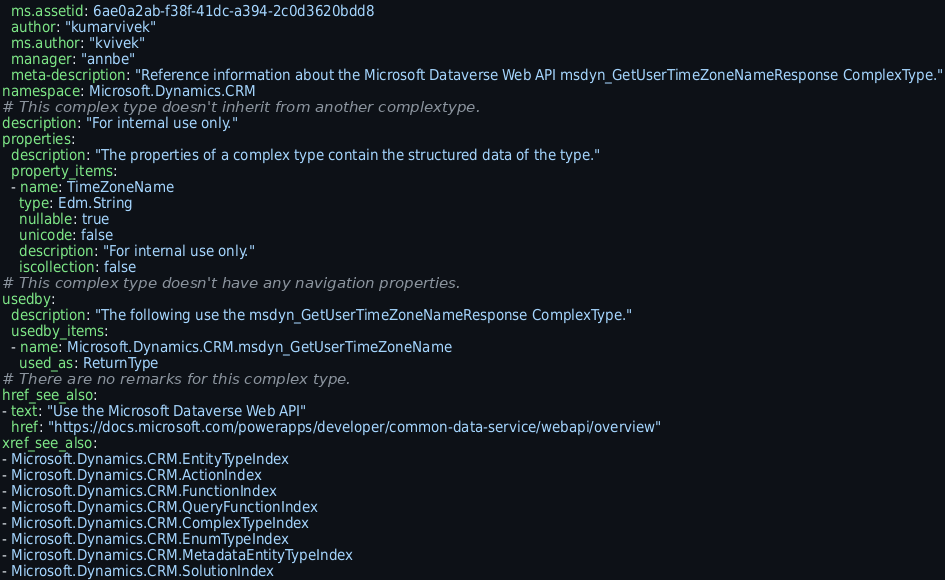<code> <loc_0><loc_0><loc_500><loc_500><_YAML_>  ms.assetid: 6ae0a2ab-f38f-41dc-a394-2c0d3620bdd8
  author: "kumarvivek"
  ms.author: "kvivek"
  manager: "annbe"
  meta-description: "Reference information about the Microsoft Dataverse Web API msdyn_GetUserTimeZoneNameResponse ComplexType."
namespace: Microsoft.Dynamics.CRM
# This complex type doesn't inherit from another complextype.
description: "For internal use only." 
properties:
  description: "The properties of a complex type contain the structured data of the type."
  property_items:
  - name: TimeZoneName
    type: Edm.String
    nullable: true
    unicode: false
    description: "For internal use only."
    iscollection: false
# This complex type doesn't have any navigation properties.
usedby:
  description: "The following use the msdyn_GetUserTimeZoneNameResponse ComplexType."
  usedby_items:
  - name: Microsoft.Dynamics.CRM.msdyn_GetUserTimeZoneName
    used_as: ReturnType
# There are no remarks for this complex type.
href_see_also:
- text: "Use the Microsoft Dataverse Web API"
  href: "https://docs.microsoft.com/powerapps/developer/common-data-service/webapi/overview"
xref_see_also:
- Microsoft.Dynamics.CRM.EntityTypeIndex
- Microsoft.Dynamics.CRM.ActionIndex
- Microsoft.Dynamics.CRM.FunctionIndex
- Microsoft.Dynamics.CRM.QueryFunctionIndex
- Microsoft.Dynamics.CRM.ComplexTypeIndex
- Microsoft.Dynamics.CRM.EnumTypeIndex
- Microsoft.Dynamics.CRM.MetadataEntityTypeIndex
- Microsoft.Dynamics.CRM.SolutionIndex
</code> 